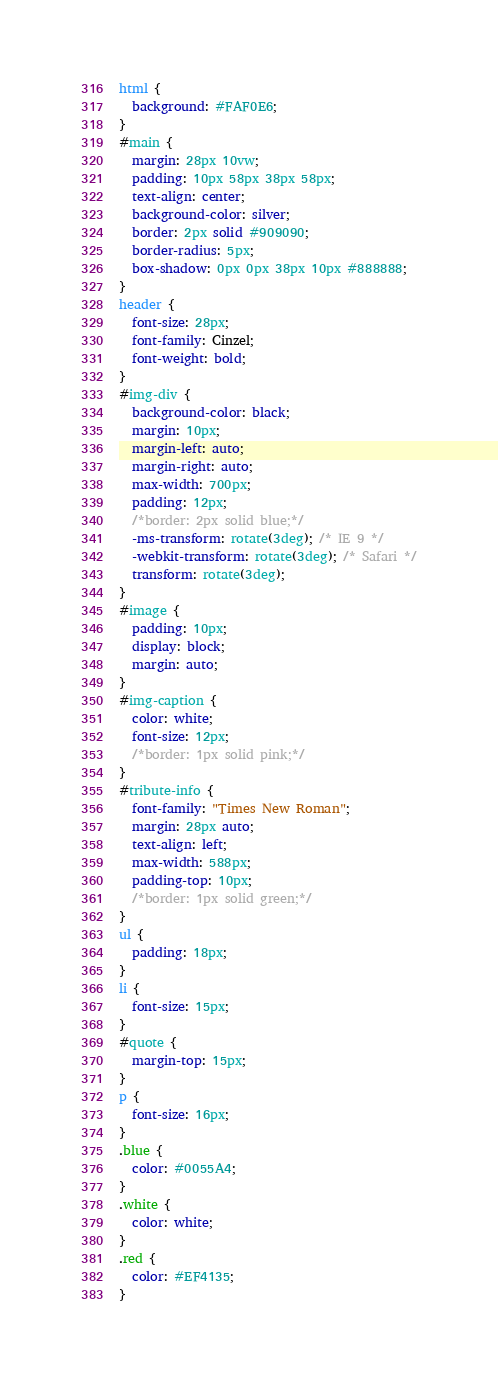<code> <loc_0><loc_0><loc_500><loc_500><_CSS_>html {
  background: #FAF0E6;
}
#main {
  margin: 28px 10vw;
  padding: 10px 58px 38px 58px;
  text-align: center;
  background-color: silver;
  border: 2px solid #909090;
  border-radius: 5px;
  box-shadow: 0px 0px 38px 10px #888888;
}
header {
  font-size: 28px;
  font-family: Cinzel;
  font-weight: bold;
}
#img-div {
  background-color: black;
  margin: 10px;
  margin-left: auto;
  margin-right: auto;
  max-width: 700px;
  padding: 12px;
  /*border: 2px solid blue;*/
  -ms-transform: rotate(3deg); /* IE 9 */
  -webkit-transform: rotate(3deg); /* Safari */
  transform: rotate(3deg);
}
#image {
  padding: 10px;
  display: block;
  margin: auto;
}
#img-caption {
  color: white;
  font-size: 12px;
  /*border: 1px solid pink;*/
}
#tribute-info {
  font-family: "Times New Roman";
  margin: 28px auto;
  text-align: left;
  max-width: 588px;
  padding-top: 10px;
  /*border: 1px solid green;*/
}
ul {
  padding: 18px;
}
li {
  font-size: 15px;
}
#quote {
  margin-top: 15px;
}
p {
  font-size: 16px;
}
.blue {
  color: #0055A4;
}
.white {
  color: white;
}
.red {
  color: #EF4135;
}
</code> 